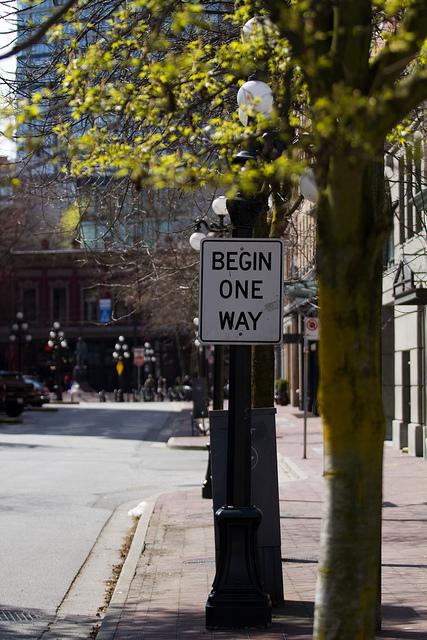Is the road clear?
Keep it brief. Yes. What begins in this picture?
Answer briefly. One way. What color is the sidewalk?
Keep it brief. Red. 